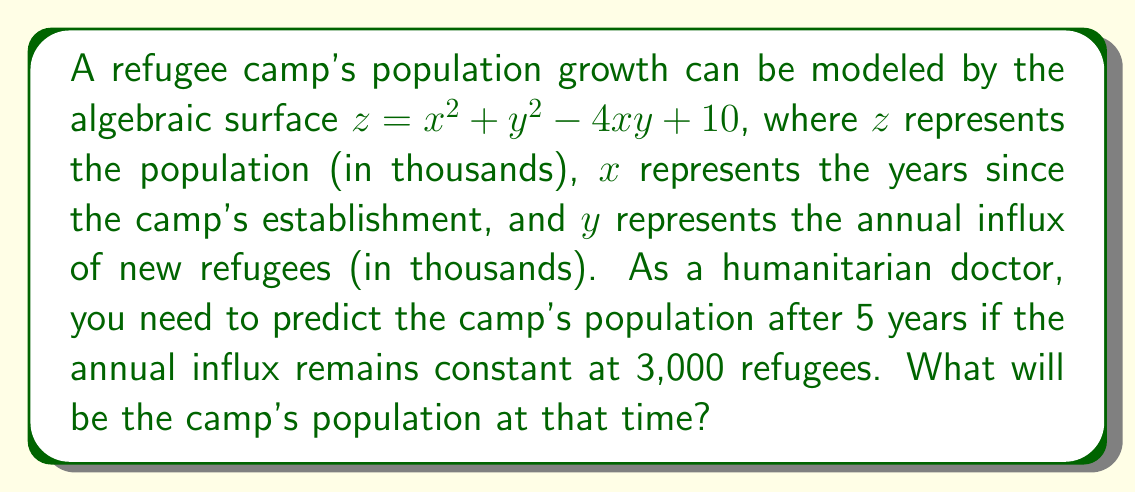Can you answer this question? To solve this problem, we'll follow these steps:

1) We're given the algebraic surface equation:
   $z = x^2 + y^2 - 4xy + 10$

2) We need to find $z$ when:
   $x = 5$ (5 years since establishment)
   $y = 3$ (3,000 new refugees annually)

3) Let's substitute these values into the equation:
   $z = 5^2 + 3^2 - 4(5)(3) + 10$

4) Now, let's calculate each term:
   $5^2 = 25$
   $3^2 = 9$
   $4(5)(3) = 60$

5) Substituting these values:
   $z = 25 + 9 - 60 + 10$

6) Simplifying:
   $z = 34 - 60 + 10 = -16$

7) Remember, $z$ represents the population in thousands. Since we can't have a negative population, this result suggests that the camp's population has decreased to zero and the model is no longer applicable in this range.

8) In a real-world scenario, this could indicate that the camp has been closed or evacuated within the 5-year period. As a humanitarian doctor, you would need to investigate the reasons for this population decline and potentially adjust the model or consider other factors affecting the camp's population dynamics.
Answer: 0 (The model predicts camp closure or evacuation within 5 years) 